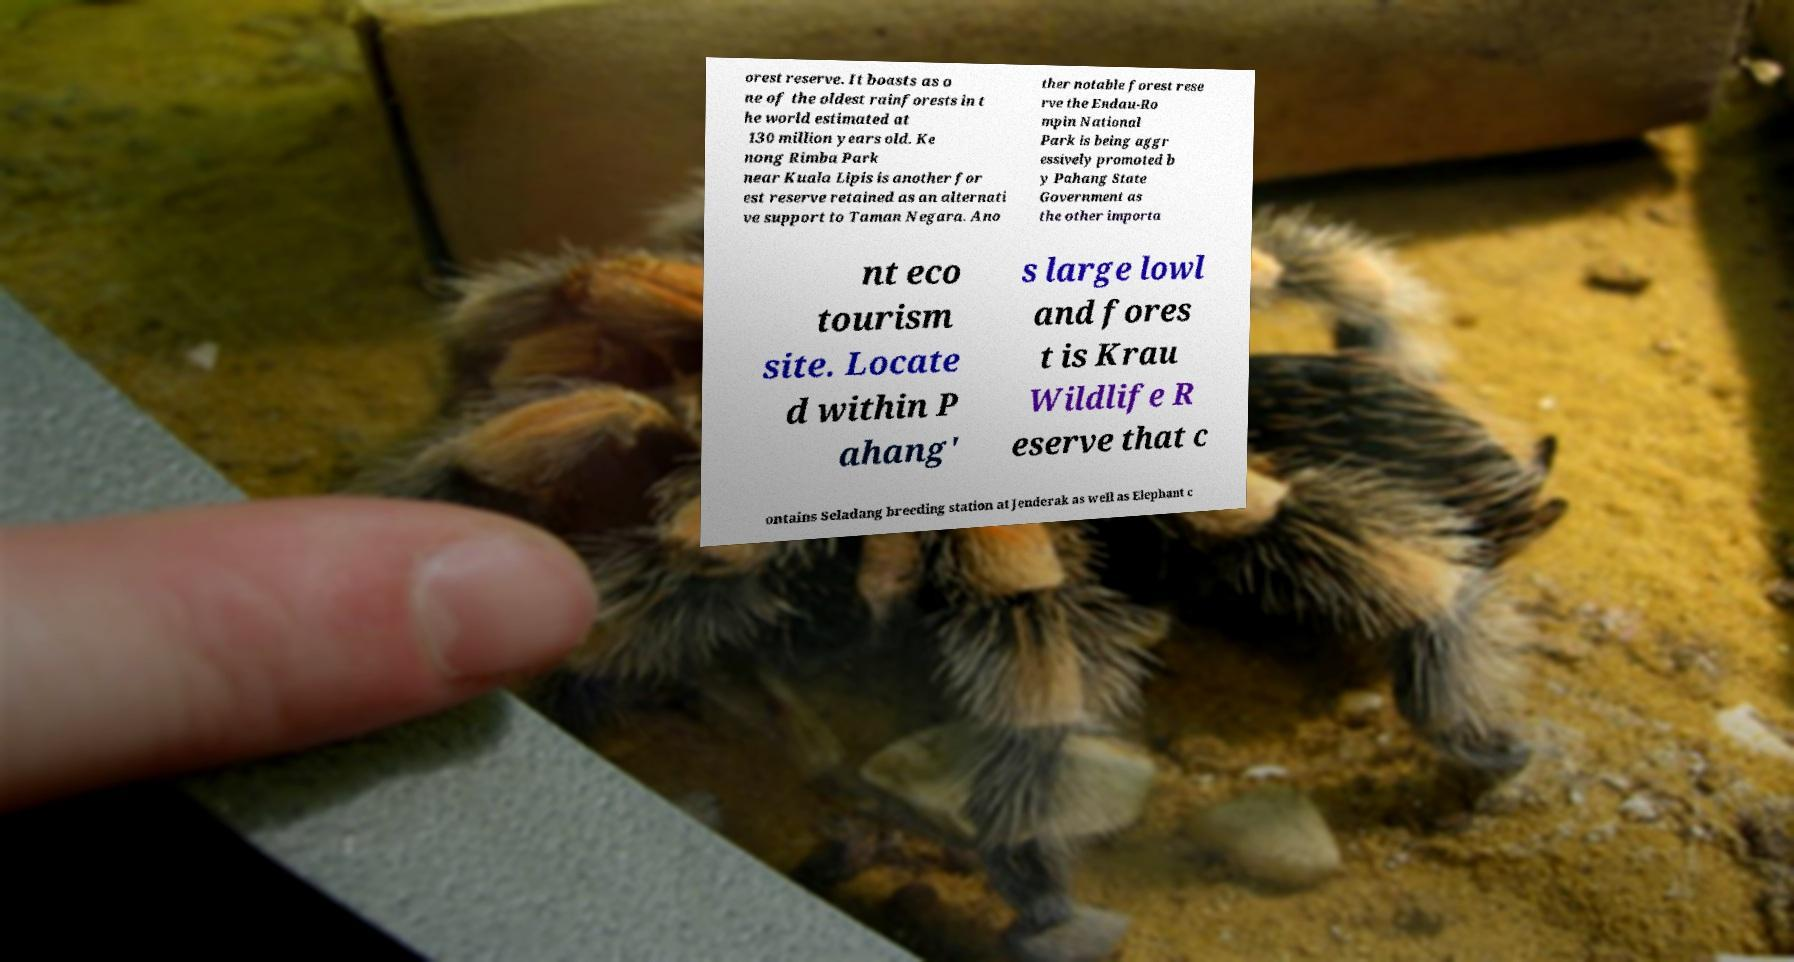What messages or text are displayed in this image? I need them in a readable, typed format. orest reserve. It boasts as o ne of the oldest rainforests in t he world estimated at 130 million years old. Ke nong Rimba Park near Kuala Lipis is another for est reserve retained as an alternati ve support to Taman Negara. Ano ther notable forest rese rve the Endau-Ro mpin National Park is being aggr essively promoted b y Pahang State Government as the other importa nt eco tourism site. Locate d within P ahang' s large lowl and fores t is Krau Wildlife R eserve that c ontains Seladang breeding station at Jenderak as well as Elephant c 